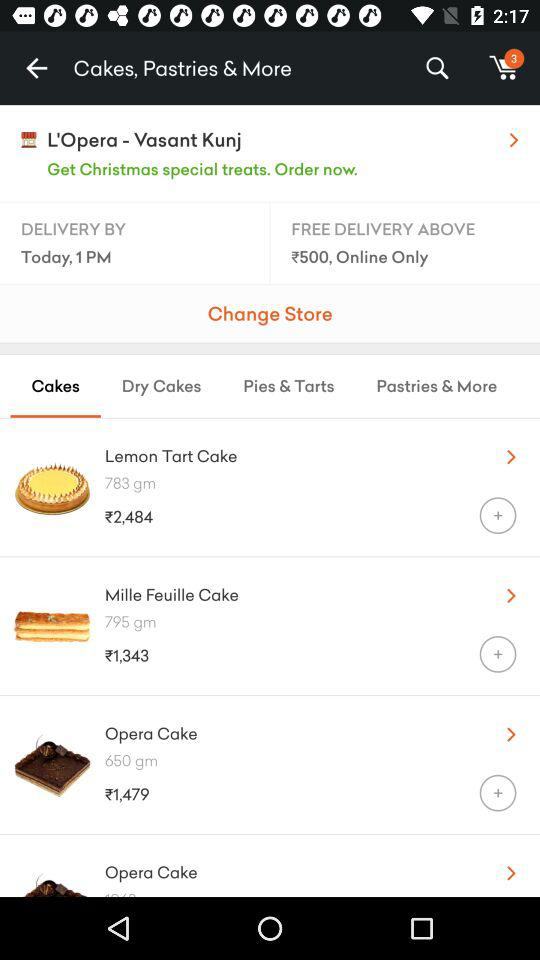What is the price of the "Lemon Tart Cake"? The price of the "Lemon Tart Cake" is ₹2,484. 